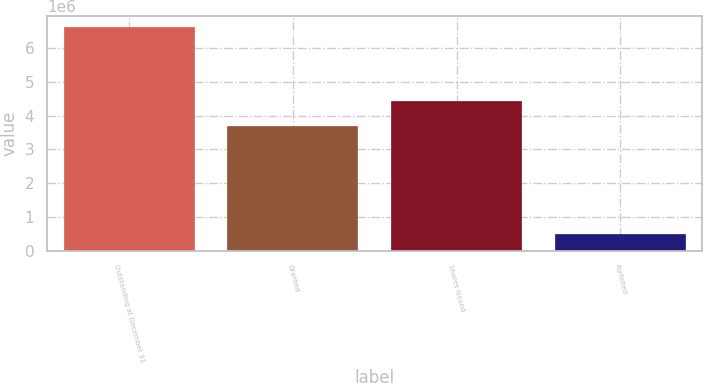Convert chart. <chart><loc_0><loc_0><loc_500><loc_500><bar_chart><fcel>Outstanding at December 31<fcel>Granted<fcel>Shares issued<fcel>Forfeited<nl><fcel>6.61957e+06<fcel>3.68266e+06<fcel>4.4445e+06<fcel>499107<nl></chart> 